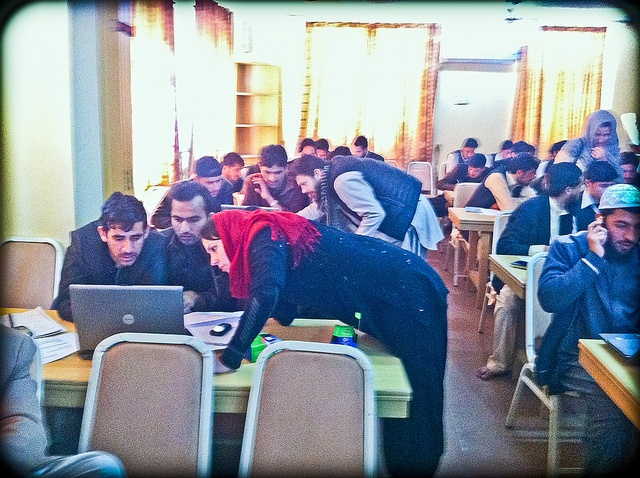Describe the objects in this image and their specific colors. I can see people in black, navy, blue, and darkblue tones, dining table in black, gray, lavender, and darkgray tones, people in black, navy, and blue tones, chair in black, darkgray, lightblue, and gray tones, and chair in black, darkgray, gray, and lightblue tones in this image. 